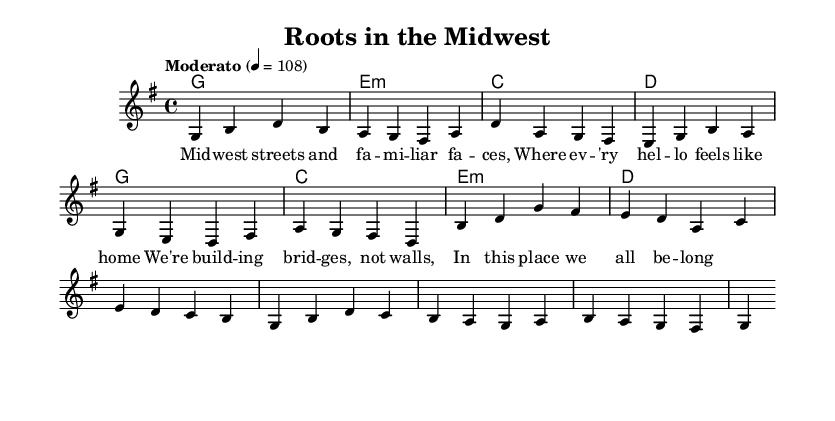What is the key signature of this music? The key signature shown at the beginning of the piece indicates that there is an F# sharp and a C# sharp. Hence, the piece is in G major since it contains one sharp which corresponds to the F#.
Answer: G major What is the time signature of this music? The time signature appears right after the key signature, represented in the format of x/y, where x is the number of beats in a measure and y is the note value that represents one beat. Here, it is 4/4, meaning there are four beats per measure and a quarter note gets one beat.
Answer: 4/4 What is the tempo marking of the piece? The tempo marking is indicated at the beginning of the score, showing "Moderato" and a metronome marking of 108, which provides the speed of the piece in beats per minute.
Answer: Moderato 108 How many measures are in the verse section? By counting the number of distinct groupings in the melody section marked as the verse, we find that there are six measures present before transitioning to the chorus.
Answer: 6 What is the primary theme explored in the lyrics? Analyzing the lyrics, the repeated phrase "building bridges, not walls" conveys a focus on community and inclusivity, highlighting the theme of connection and belonging among individuals.
Answer: Community and belonging How does the harmonic progression support the melody in the chorus? By examining the chords written with specific notes played underneath the melody, we can deduce that each chord corresponds to a measure aligned with the melody notes, creating a unified sound that enhances the expressed emotion of the chorus’s message.
Answer: Enhanced emotion How does the lyric "Midwest streets and familiar faces" contribute to the song's narrative? This lyric situates the listener in a specific geographical and emotional context, immediately evoking a sense of place and shared experience, which is essential in themes of community and belonging present throughout the song.
Answer: Evokes sense of place 